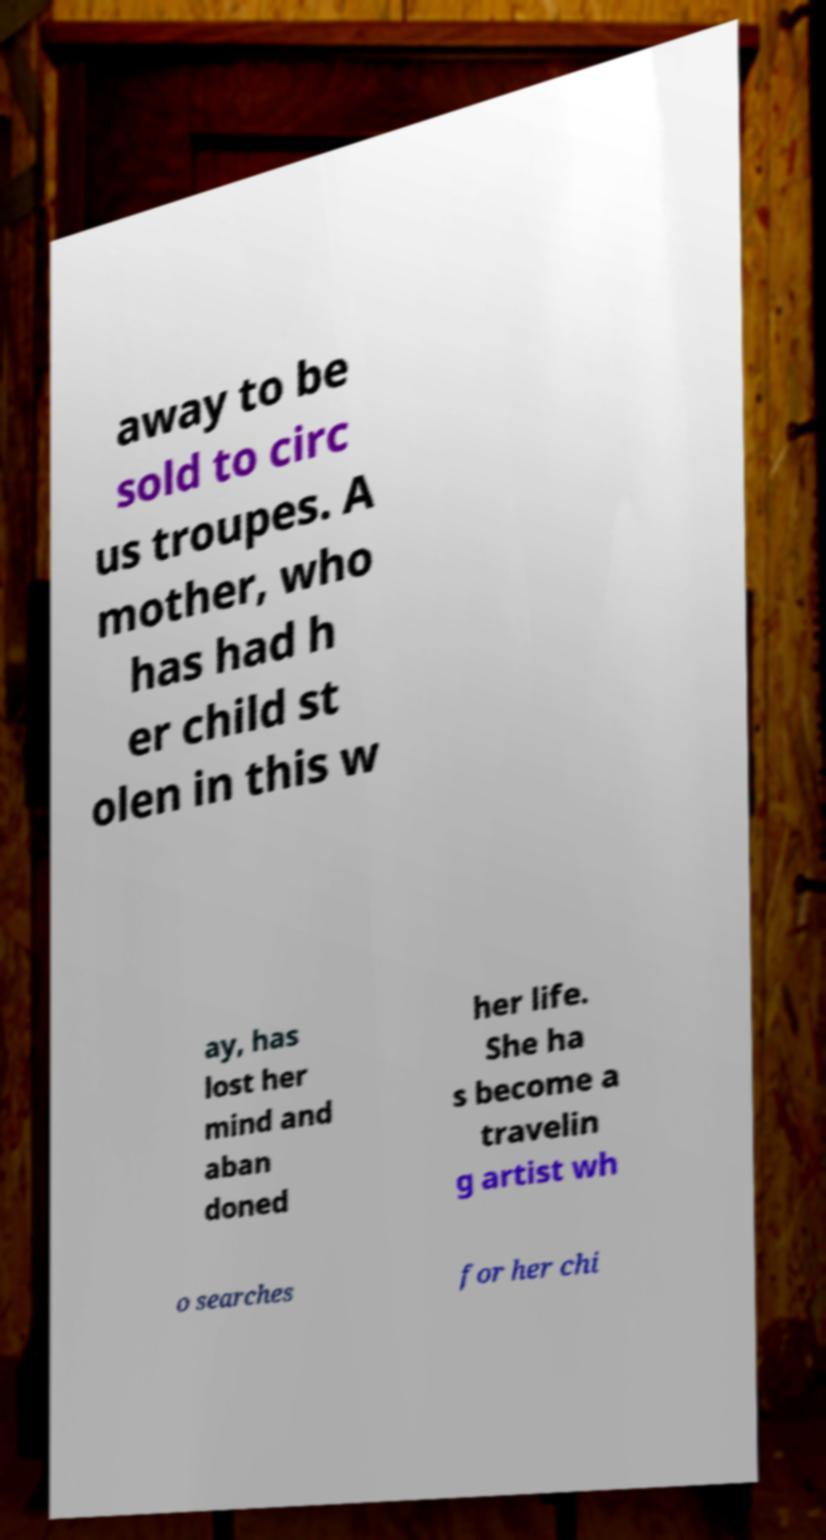Could you assist in decoding the text presented in this image and type it out clearly? away to be sold to circ us troupes. A mother, who has had h er child st olen in this w ay, has lost her mind and aban doned her life. She ha s become a travelin g artist wh o searches for her chi 